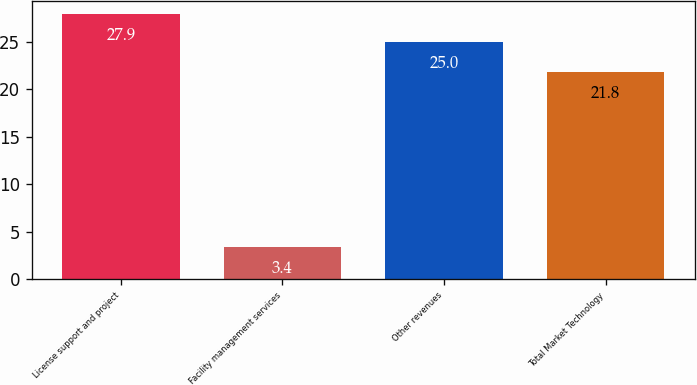Convert chart to OTSL. <chart><loc_0><loc_0><loc_500><loc_500><bar_chart><fcel>License support and project<fcel>Facility management services<fcel>Other revenues<fcel>Total Market Technology<nl><fcel>27.9<fcel>3.4<fcel>25<fcel>21.8<nl></chart> 